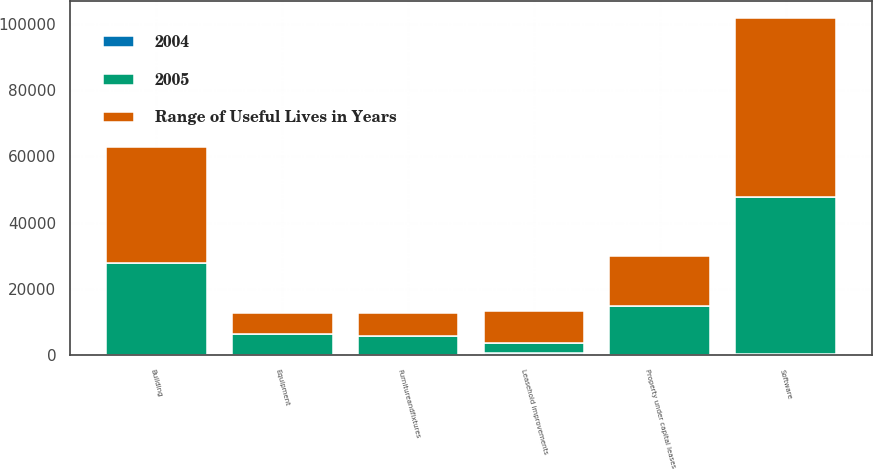<chart> <loc_0><loc_0><loc_500><loc_500><stacked_bar_chart><ecel><fcel>Property under capital leases<fcel>Building<fcel>Equipment<fcel>Software<fcel>Leasehold improvements<fcel>Furnitureandfixtures<nl><fcel>2004<fcel>25<fcel>40<fcel>25<fcel>510<fcel>540<fcel>57<nl><fcel>Range of Useful Lives in Years<fcel>14989<fcel>35068<fcel>6362<fcel>53940<fcel>9522<fcel>7034<nl><fcel>2005<fcel>14989<fcel>27805<fcel>6362<fcel>47381<fcel>3241<fcel>5690<nl></chart> 